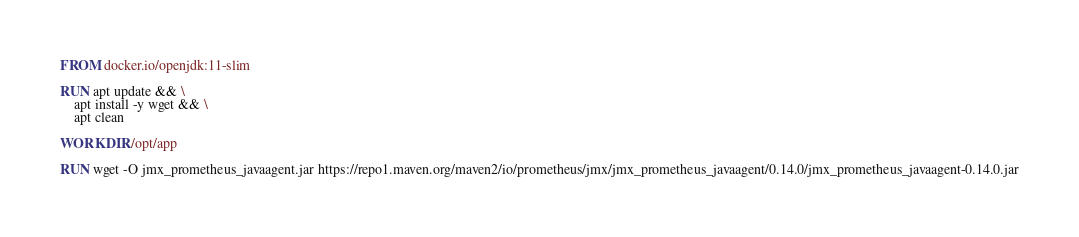Convert code to text. <code><loc_0><loc_0><loc_500><loc_500><_Dockerfile_>FROM docker.io/openjdk:11-slim

RUN apt update && \
    apt install -y wget && \
    apt clean

WORKDIR /opt/app

RUN wget -O jmx_prometheus_javaagent.jar https://repo1.maven.org/maven2/io/prometheus/jmx/jmx_prometheus_javaagent/0.14.0/jmx_prometheus_javaagent-0.14.0.jar</code> 